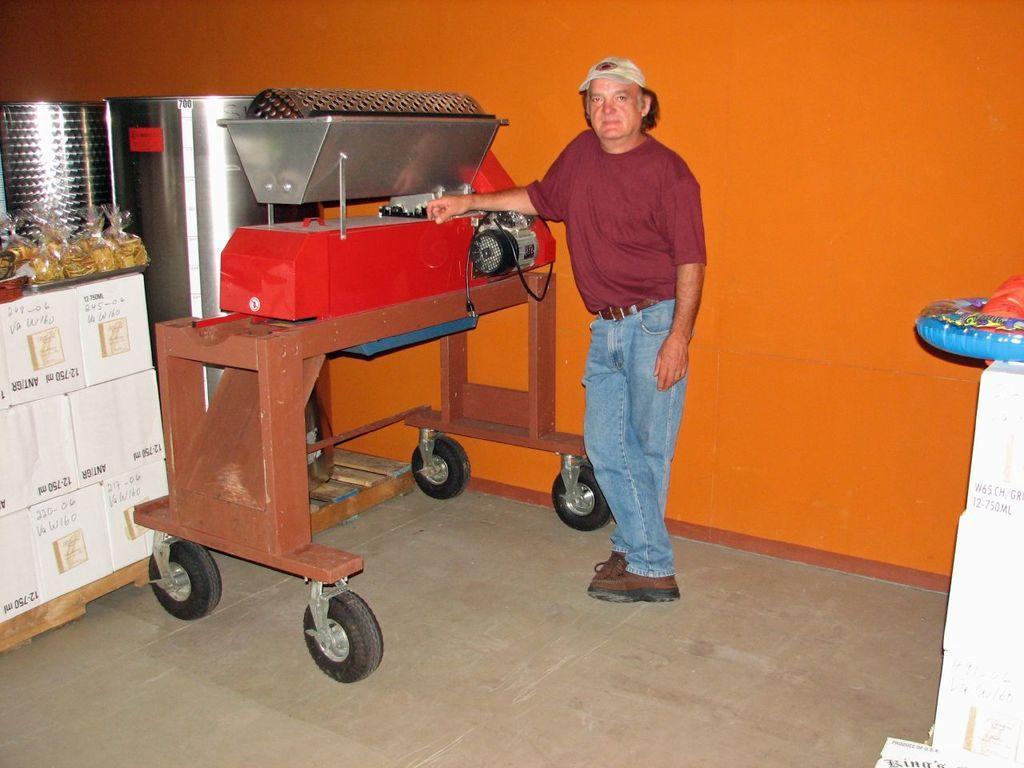Describe this image in one or two sentences. Beside this man there is a table with wheels. Above this table there is an electrical machine. These are containers. On this table there are food packets. Wall is in orange color.  